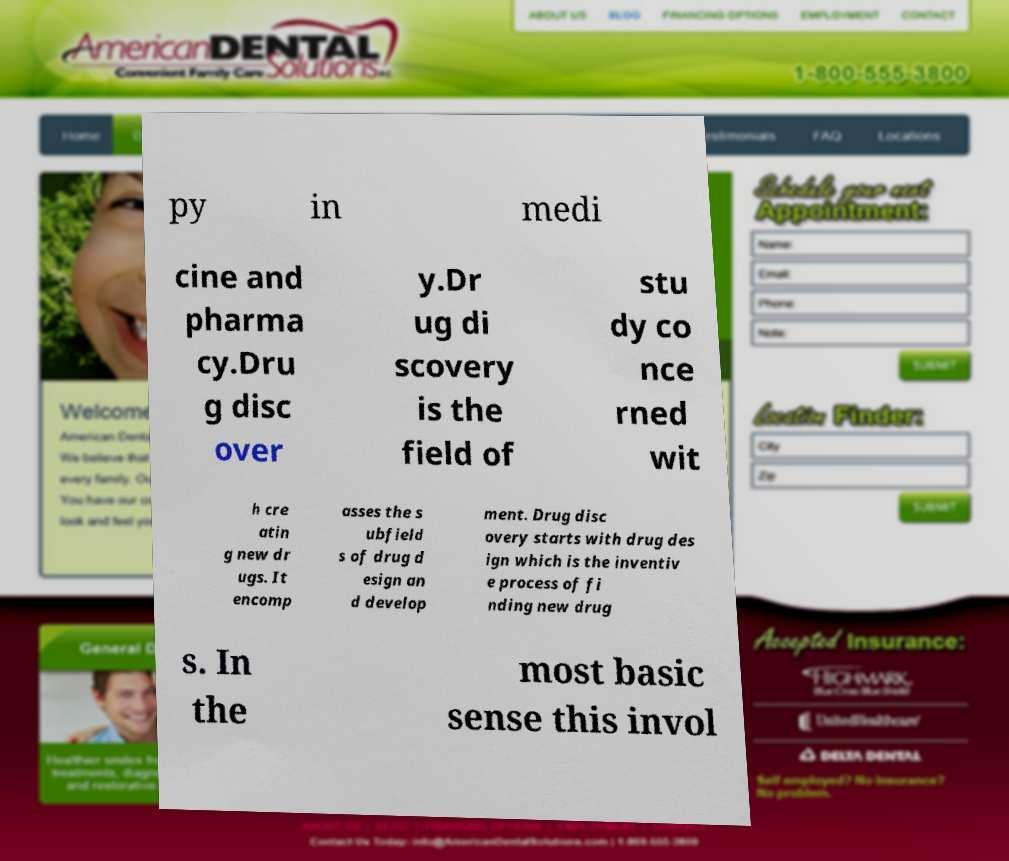Could you extract and type out the text from this image? py in medi cine and pharma cy.Dru g disc over y.Dr ug di scovery is the field of stu dy co nce rned wit h cre atin g new dr ugs. It encomp asses the s ubfield s of drug d esign an d develop ment. Drug disc overy starts with drug des ign which is the inventiv e process of fi nding new drug s. In the most basic sense this invol 